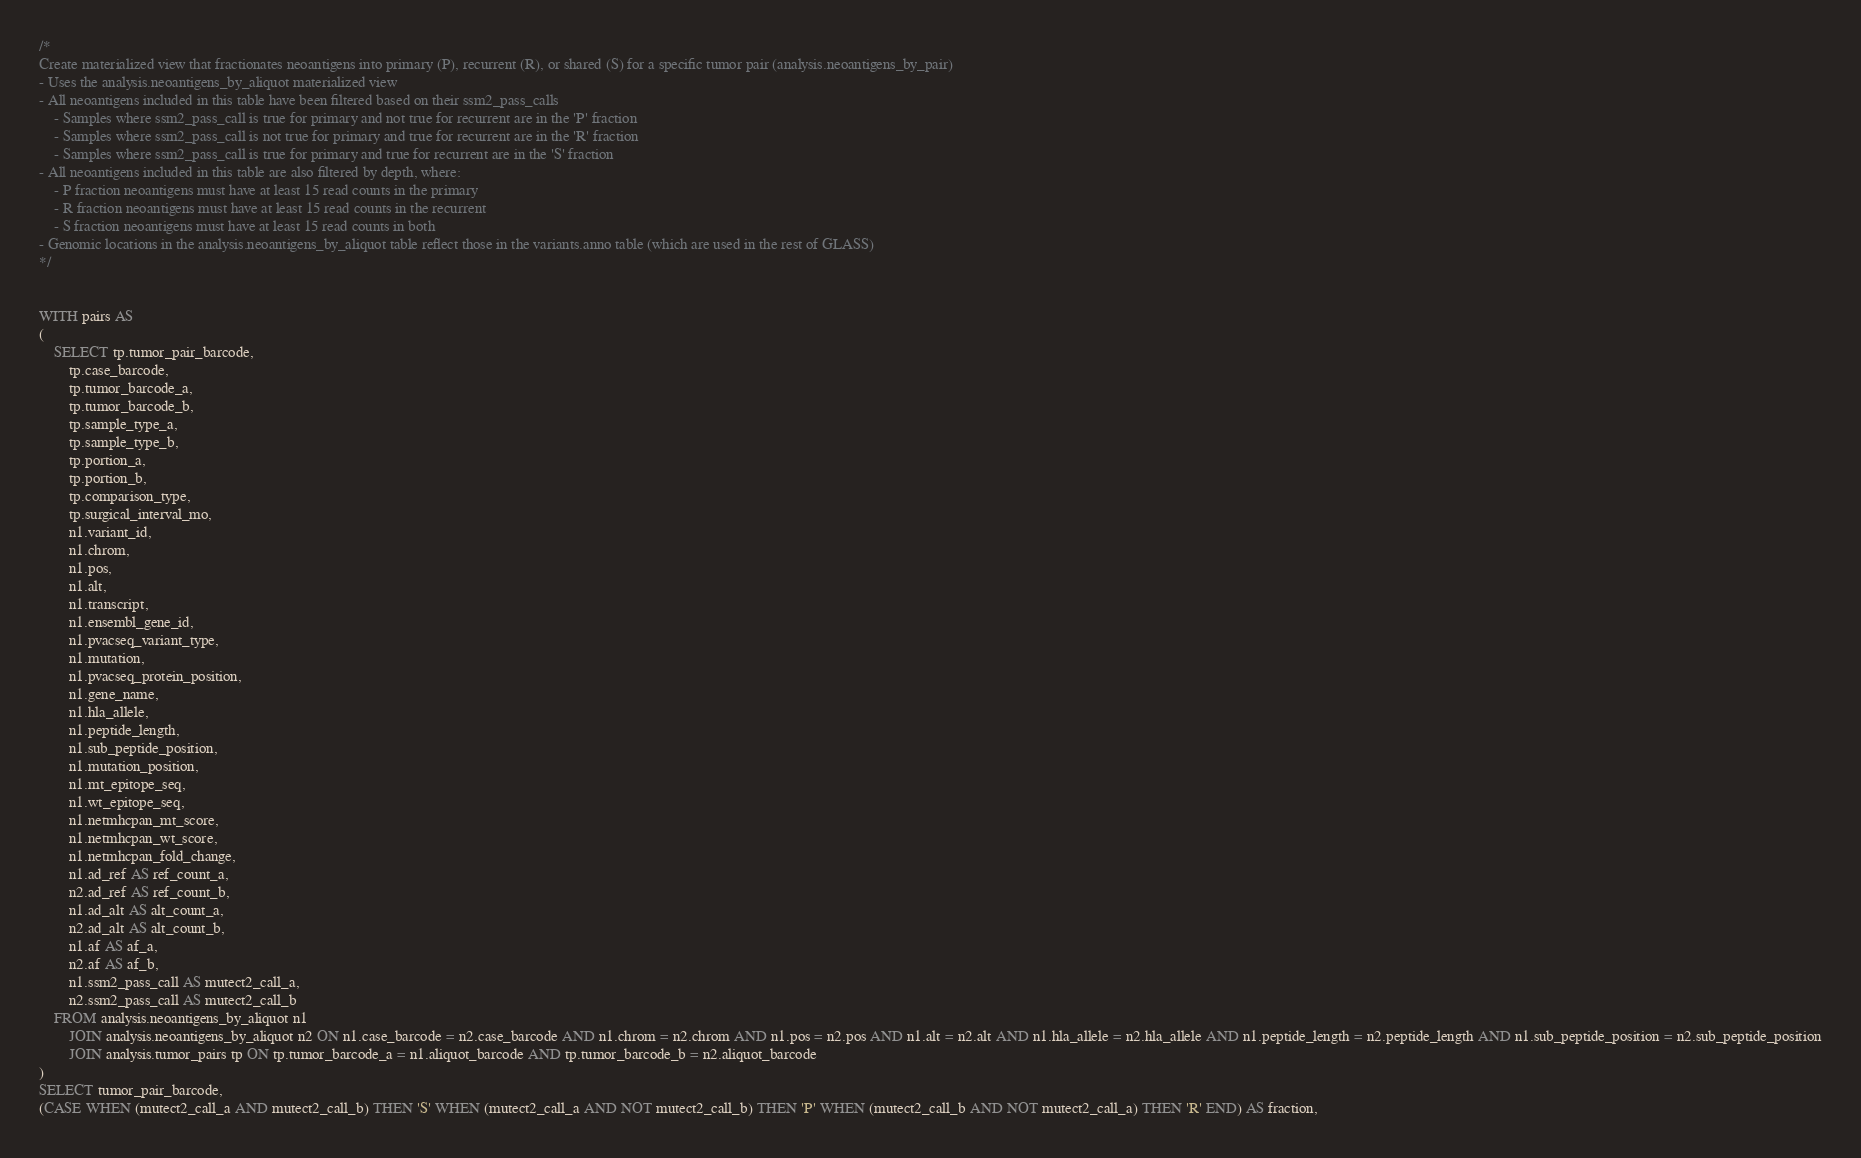Convert code to text. <code><loc_0><loc_0><loc_500><loc_500><_SQL_>/*
Create materialized view that fractionates neoantigens into primary (P), recurrent (R), or shared (S) for a specific tumor pair (analysis.neoantigens_by_pair)
- Uses the analysis.neoantigens_by_aliquot materialized view
- All neoantigens included in this table have been filtered based on their ssm2_pass_calls
	- Samples where ssm2_pass_call is true for primary and not true for recurrent are in the 'P' fraction
	- Samples where ssm2_pass_call is not true for primary and true for recurrent are in the 'R' fraction
	- Samples where ssm2_pass_call is true for primary and true for recurrent are in the 'S' fraction
- All neoantigens included in this table are also filtered by depth, where:
	- P fraction neoantigens must have at least 15 read counts in the primary
	- R fraction neoantigens must have at least 15 read counts in the recurrent
	- S fraction neoantigens must have at least 15 read counts in both
- Genomic locations in the analysis.neoantigens_by_aliquot table reflect those in the variants.anno table (which are used in the rest of GLASS)
*/


WITH pairs AS
(
	SELECT tp.tumor_pair_barcode,
		tp.case_barcode,
		tp.tumor_barcode_a,
		tp.tumor_barcode_b,
		tp.sample_type_a,
		tp.sample_type_b,
		tp.portion_a,
		tp.portion_b,
		tp.comparison_type,
		tp.surgical_interval_mo,
		n1.variant_id,
		n1.chrom,
		n1.pos,
		n1.alt,
		n1.transcript,
		n1.ensembl_gene_id,
		n1.pvacseq_variant_type,
		n1.mutation,
		n1.pvacseq_protein_position,
		n1.gene_name,
		n1.hla_allele,
		n1.peptide_length,
		n1.sub_peptide_position,
		n1.mutation_position,
		n1.mt_epitope_seq,
		n1.wt_epitope_seq,
		n1.netmhcpan_mt_score,
		n1.netmhcpan_wt_score,
		n1.netmhcpan_fold_change,
		n1.ad_ref AS ref_count_a,
		n2.ad_ref AS ref_count_b,
		n1.ad_alt AS alt_count_a,
		n2.ad_alt AS alt_count_b,
		n1.af AS af_a,
		n2.af AS af_b,
		n1.ssm2_pass_call AS mutect2_call_a,
		n2.ssm2_pass_call AS mutect2_call_b
	FROM analysis.neoantigens_by_aliquot n1
		JOIN analysis.neoantigens_by_aliquot n2 ON n1.case_barcode = n2.case_barcode AND n1.chrom = n2.chrom AND n1.pos = n2.pos AND n1.alt = n2.alt AND n1.hla_allele = n2.hla_allele AND n1.peptide_length = n2.peptide_length AND n1.sub_peptide_position = n2.sub_peptide_position
		JOIN analysis.tumor_pairs tp ON tp.tumor_barcode_a = n1.aliquot_barcode AND tp.tumor_barcode_b = n2.aliquot_barcode
)
SELECT tumor_pair_barcode,
(CASE WHEN (mutect2_call_a AND mutect2_call_b) THEN 'S' WHEN (mutect2_call_a AND NOT mutect2_call_b) THEN 'P' WHEN (mutect2_call_b AND NOT mutect2_call_a) THEN 'R' END) AS fraction,</code> 